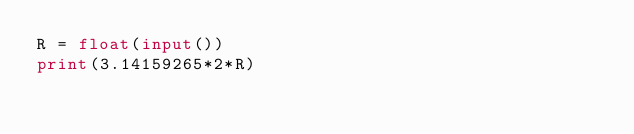Convert code to text. <code><loc_0><loc_0><loc_500><loc_500><_Python_>R = float(input())
print(3.14159265*2*R)</code> 